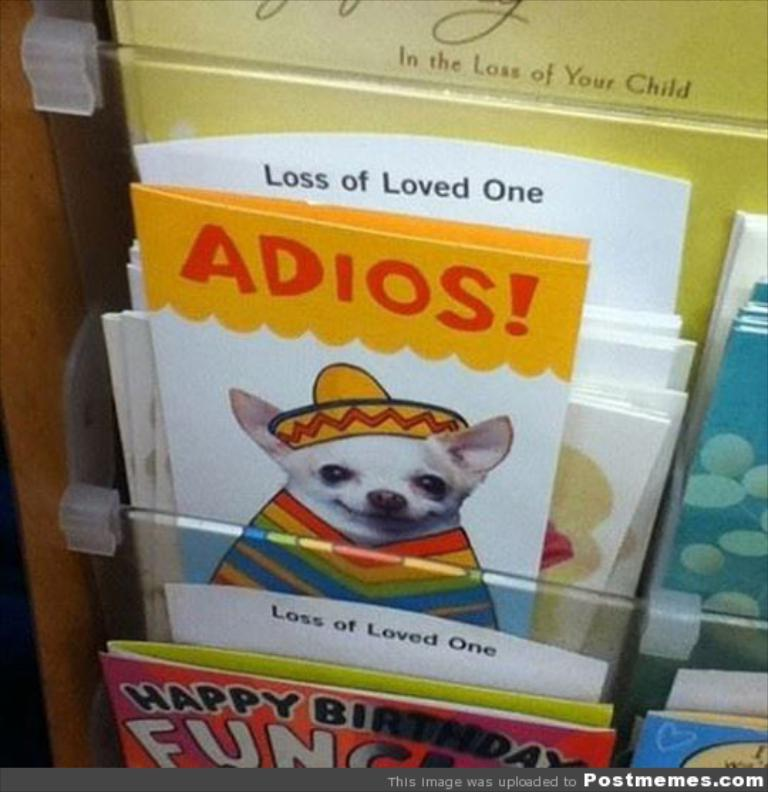What objects are present in the picture? There are greeting cards in the picture. Can you describe one of the greeting cards in more detail? Yes, one of the greeting cards has a dog depicted on it. How many feet does the dog have on the greeting card? The greeting card is a two-dimensional image, so it does not have feet. The dog depicted on the card has four legs, but the card itself does not have feet. 